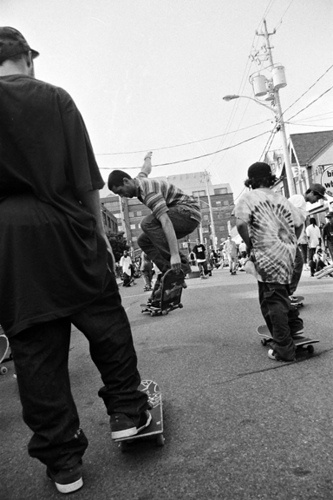Describe the objects in this image and their specific colors. I can see people in lightgray, black, gray, and darkgray tones, people in lightgray, black, darkgray, and gray tones, people in lightgray, black, gray, and darkgray tones, skateboard in lightgray, gray, black, and darkgray tones, and people in lightgray, black, gray, and darkgray tones in this image. 